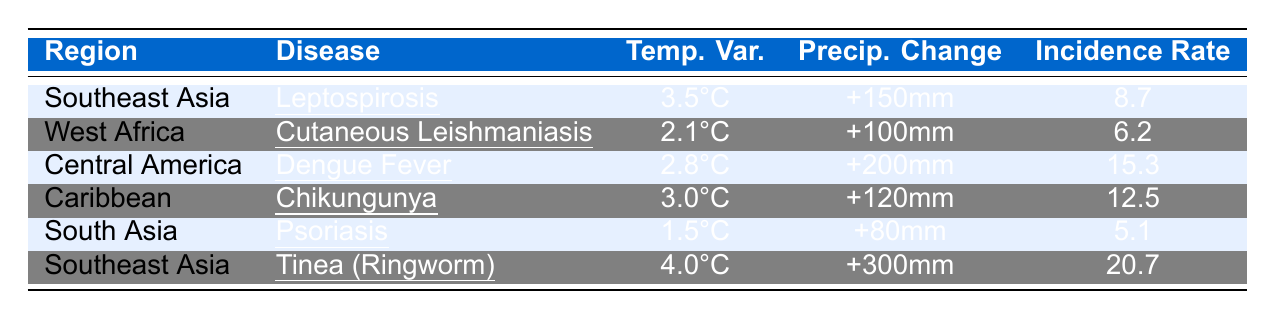What is the incidence rate of Tinea (Ringworm) in Southeast Asia? The table indicates that the incidence rate per 1000 for Tinea (Ringworm) in Southeast Asia is 20.7.
Answer: 20.7 Which disease has the highest incidence rate? By comparing the incidence rates, Tinea (Ringworm) at 20.7 has the highest rate, followed by Dengue Fever at 15.3.
Answer: Tinea (Ringworm) What is the temperature variability for Psoriasis in South Asia? The table shows that the temperature variability for Psoriasis in South Asia is 1.5°C.
Answer: 1.5°C How much precipitation change is reported for Central America? The table specifies that the precipitation change for Central America is +200mm.
Answer: +200mm Is the incidence rate of Cutaneous Leishmaniasis greater than 10 per 1000? The incidence rate for Cutaneous Leishmaniasis in West Africa is 6.2 per 1000, which is less than 10.
Answer: No What is the average incidence rate of diseases listed in Southeast Asia? The incidence rates in Southeast Asia are 8.7 for Leptospirosis and 20.7 for Tinea (Ringworm). The average is (8.7 + 20.7) / 2 = 14.7.
Answer: 14.7 Which region reported the highest temperature variability and what is its value? The data shows that Southeast Asia reported the highest temperature variability at 4.0°C for Tinea (Ringworm).
Answer: Southeast Asia, 4.0°C What diseases are present in Southeast Asia, and how do their incidence rates compare? Southeast Asia has Leptospirosis (8.7) and Tinea (Ringworm) (20.7). Tinea (Ringworm) has a significantly higher incidence rate than Leptospirosis.
Answer: Leptospirosis and Tinea (Ringworm), with Tinea (Ringworm) higher What disease has the lowest incidence rate among the listed diseases? The table reveals that Psoriasis has the lowest incidence rate at 5.1 per 1000 compared to other diseases listed.
Answer: Psoriasis If the temperature variability increases by 1°C in Central America, what would the new value be? The current temperature variability for Central America is 2.8°C. If it increases by 1°C, the new value would be 2.8°C + 1°C = 3.8°C.
Answer: 3.8°C 